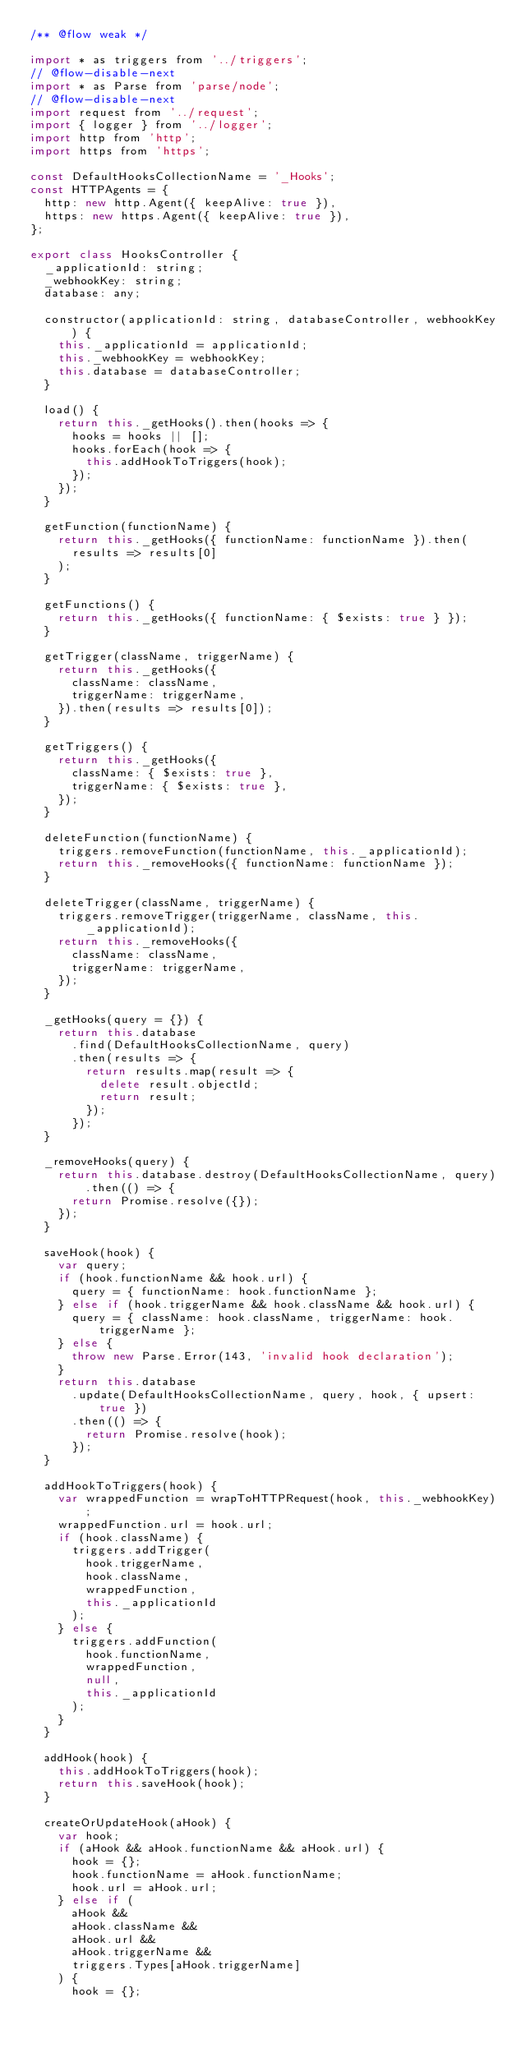<code> <loc_0><loc_0><loc_500><loc_500><_JavaScript_>/** @flow weak */

import * as triggers from '../triggers';
// @flow-disable-next
import * as Parse from 'parse/node';
// @flow-disable-next
import request from '../request';
import { logger } from '../logger';
import http from 'http';
import https from 'https';

const DefaultHooksCollectionName = '_Hooks';
const HTTPAgents = {
  http: new http.Agent({ keepAlive: true }),
  https: new https.Agent({ keepAlive: true }),
};

export class HooksController {
  _applicationId: string;
  _webhookKey: string;
  database: any;

  constructor(applicationId: string, databaseController, webhookKey) {
    this._applicationId = applicationId;
    this._webhookKey = webhookKey;
    this.database = databaseController;
  }

  load() {
    return this._getHooks().then(hooks => {
      hooks = hooks || [];
      hooks.forEach(hook => {
        this.addHookToTriggers(hook);
      });
    });
  }

  getFunction(functionName) {
    return this._getHooks({ functionName: functionName }).then(
      results => results[0]
    );
  }

  getFunctions() {
    return this._getHooks({ functionName: { $exists: true } });
  }

  getTrigger(className, triggerName) {
    return this._getHooks({
      className: className,
      triggerName: triggerName,
    }).then(results => results[0]);
  }

  getTriggers() {
    return this._getHooks({
      className: { $exists: true },
      triggerName: { $exists: true },
    });
  }

  deleteFunction(functionName) {
    triggers.removeFunction(functionName, this._applicationId);
    return this._removeHooks({ functionName: functionName });
  }

  deleteTrigger(className, triggerName) {
    triggers.removeTrigger(triggerName, className, this._applicationId);
    return this._removeHooks({
      className: className,
      triggerName: triggerName,
    });
  }

  _getHooks(query = {}) {
    return this.database
      .find(DefaultHooksCollectionName, query)
      .then(results => {
        return results.map(result => {
          delete result.objectId;
          return result;
        });
      });
  }

  _removeHooks(query) {
    return this.database.destroy(DefaultHooksCollectionName, query).then(() => {
      return Promise.resolve({});
    });
  }

  saveHook(hook) {
    var query;
    if (hook.functionName && hook.url) {
      query = { functionName: hook.functionName };
    } else if (hook.triggerName && hook.className && hook.url) {
      query = { className: hook.className, triggerName: hook.triggerName };
    } else {
      throw new Parse.Error(143, 'invalid hook declaration');
    }
    return this.database
      .update(DefaultHooksCollectionName, query, hook, { upsert: true })
      .then(() => {
        return Promise.resolve(hook);
      });
  }

  addHookToTriggers(hook) {
    var wrappedFunction = wrapToHTTPRequest(hook, this._webhookKey);
    wrappedFunction.url = hook.url;
    if (hook.className) {
      triggers.addTrigger(
        hook.triggerName,
        hook.className,
        wrappedFunction,
        this._applicationId
      );
    } else {
      triggers.addFunction(
        hook.functionName,
        wrappedFunction,
        null,
        this._applicationId
      );
    }
  }

  addHook(hook) {
    this.addHookToTriggers(hook);
    return this.saveHook(hook);
  }

  createOrUpdateHook(aHook) {
    var hook;
    if (aHook && aHook.functionName && aHook.url) {
      hook = {};
      hook.functionName = aHook.functionName;
      hook.url = aHook.url;
    } else if (
      aHook &&
      aHook.className &&
      aHook.url &&
      aHook.triggerName &&
      triggers.Types[aHook.triggerName]
    ) {
      hook = {};</code> 